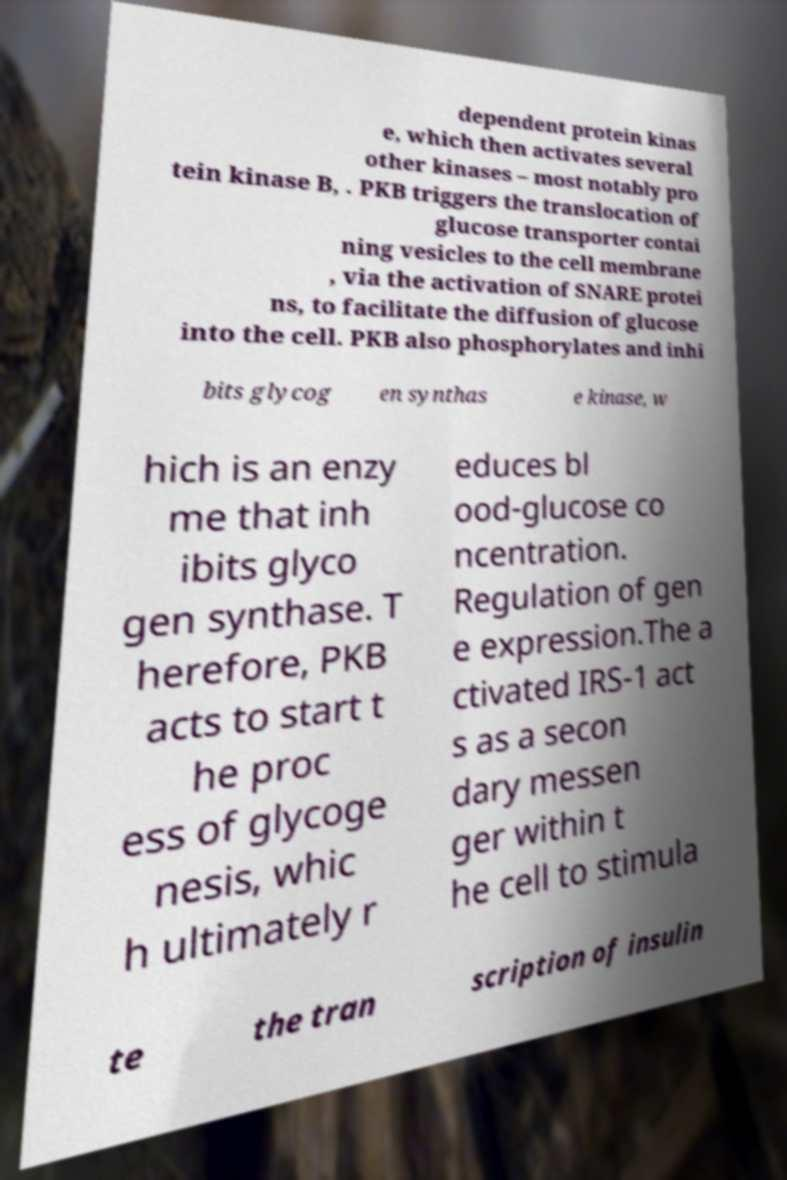Please read and relay the text visible in this image. What does it say? dependent protein kinas e, which then activates several other kinases – most notably pro tein kinase B, . PKB triggers the translocation of glucose transporter contai ning vesicles to the cell membrane , via the activation of SNARE protei ns, to facilitate the diffusion of glucose into the cell. PKB also phosphorylates and inhi bits glycog en synthas e kinase, w hich is an enzy me that inh ibits glyco gen synthase. T herefore, PKB acts to start t he proc ess of glycoge nesis, whic h ultimately r educes bl ood-glucose co ncentration. Regulation of gen e expression.The a ctivated IRS-1 act s as a secon dary messen ger within t he cell to stimula te the tran scription of insulin 